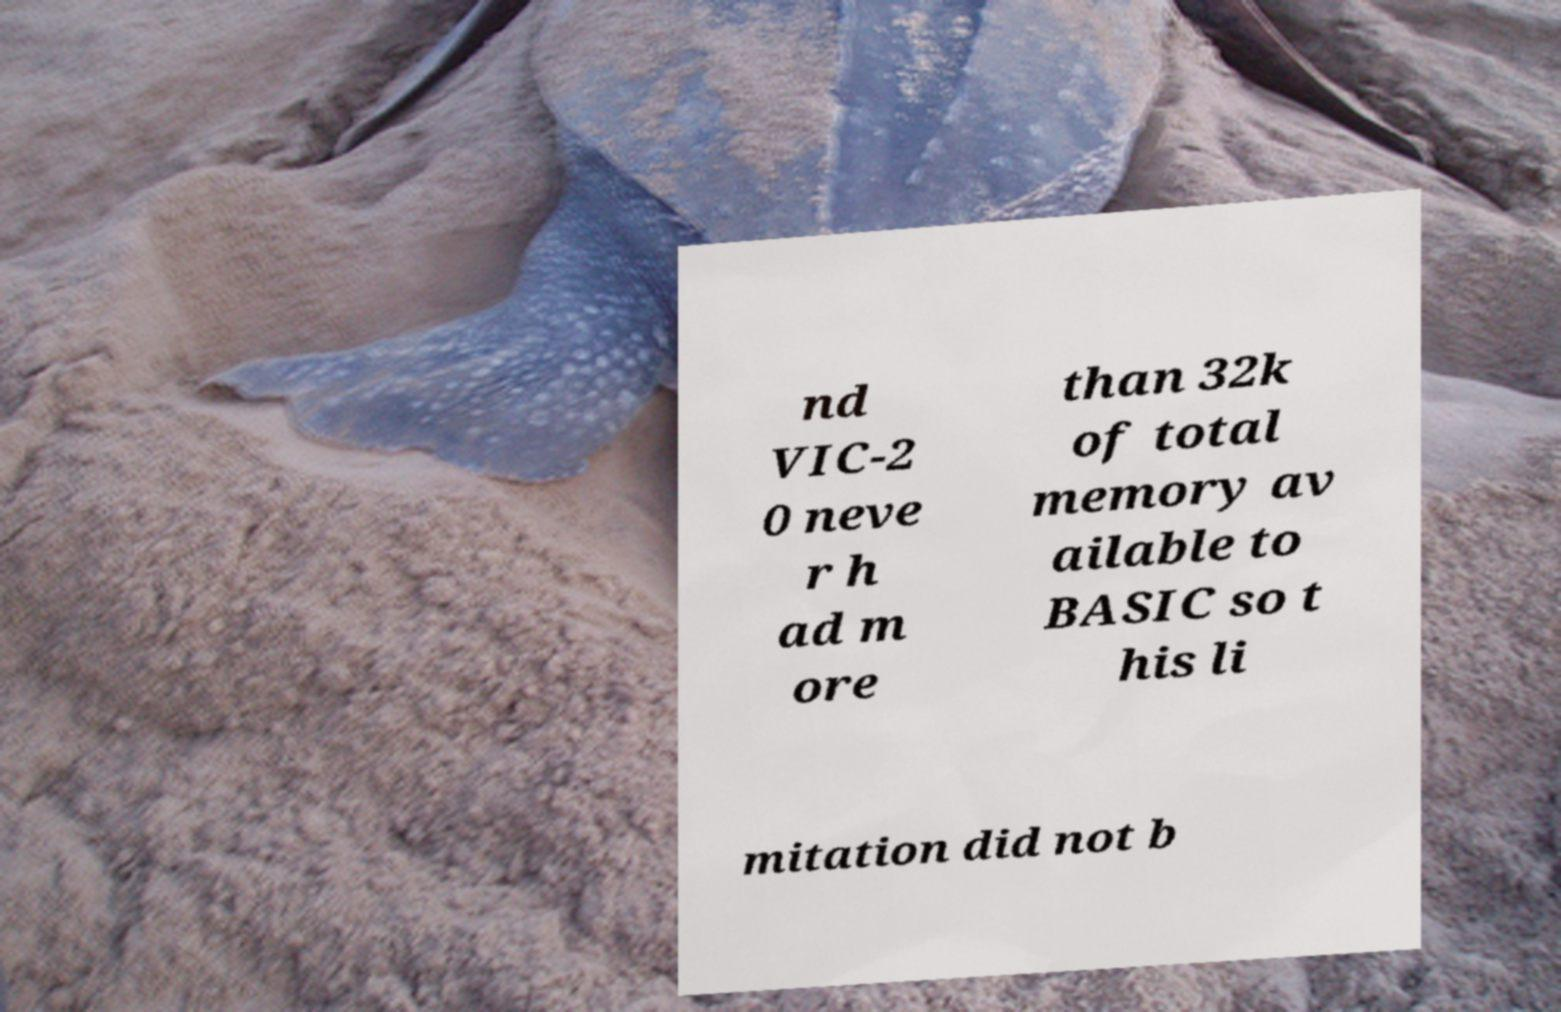Can you accurately transcribe the text from the provided image for me? nd VIC-2 0 neve r h ad m ore than 32k of total memory av ailable to BASIC so t his li mitation did not b 